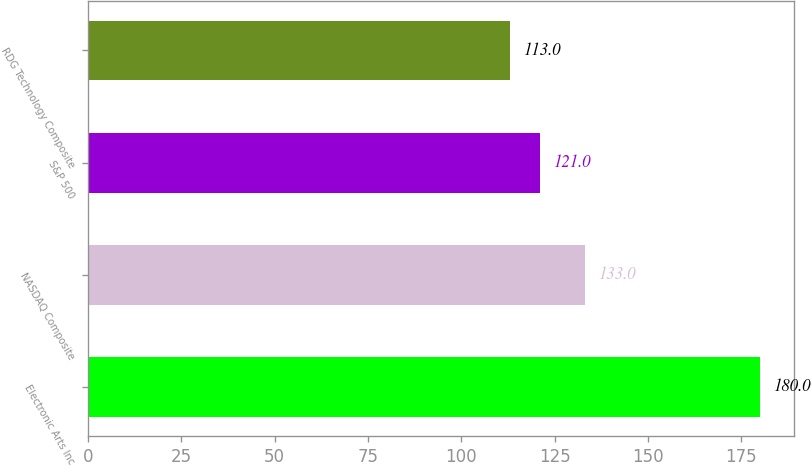Convert chart to OTSL. <chart><loc_0><loc_0><loc_500><loc_500><bar_chart><fcel>Electronic Arts Inc<fcel>NASDAQ Composite<fcel>S&P 500<fcel>RDG Technology Composite<nl><fcel>180<fcel>133<fcel>121<fcel>113<nl></chart> 